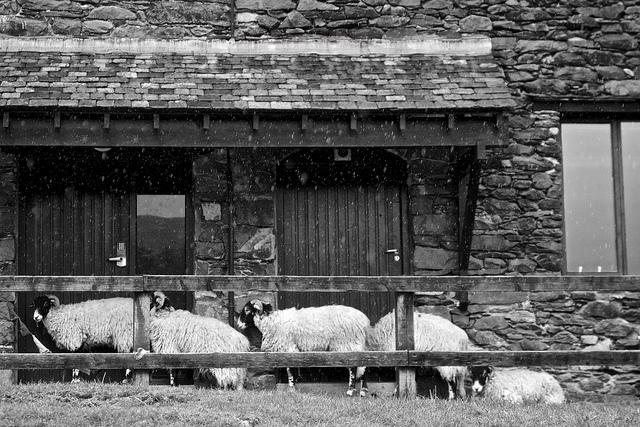What animal is this?
Write a very short answer. Sheep. Are the sheep in a barn?
Be succinct. No. Is this outdoors?
Concise answer only. Yes. 